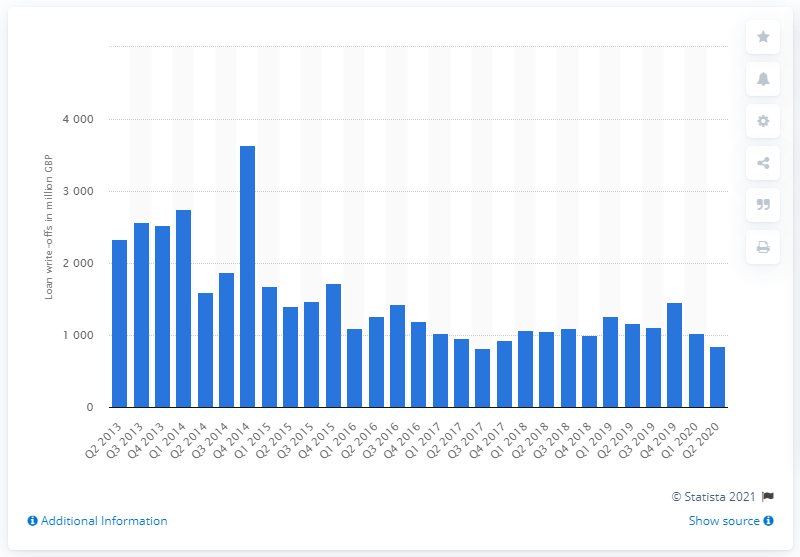Give some essential details in this illustration. In the second quarter of 2020, the total value of loan write-offs in the United Kingdom was 851. 